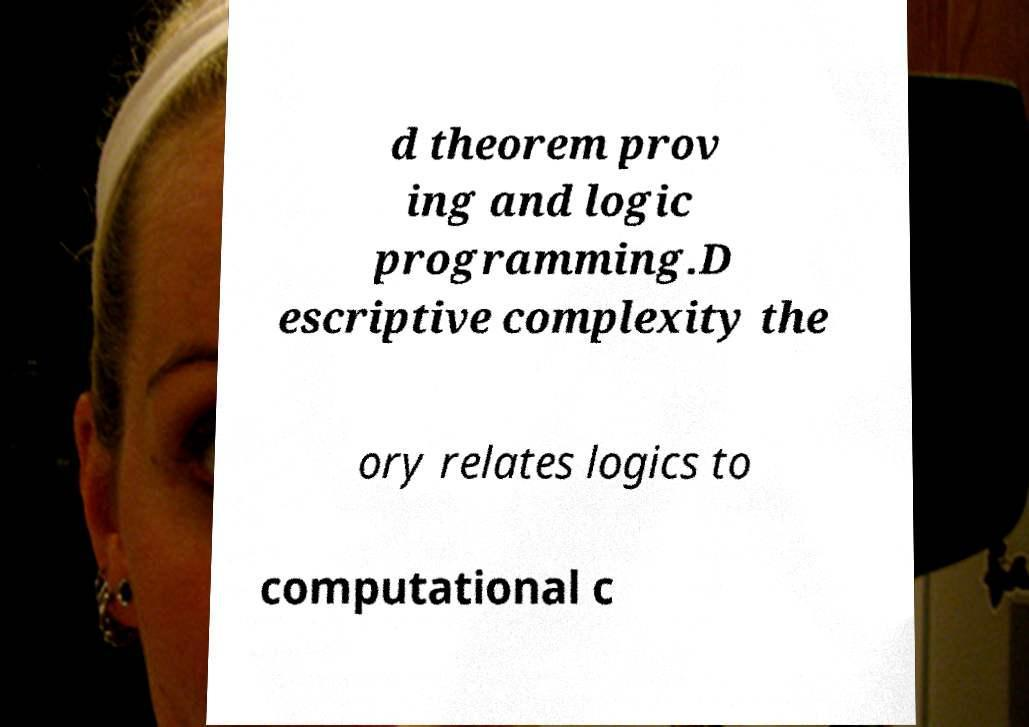There's text embedded in this image that I need extracted. Can you transcribe it verbatim? d theorem prov ing and logic programming.D escriptive complexity the ory relates logics to computational c 